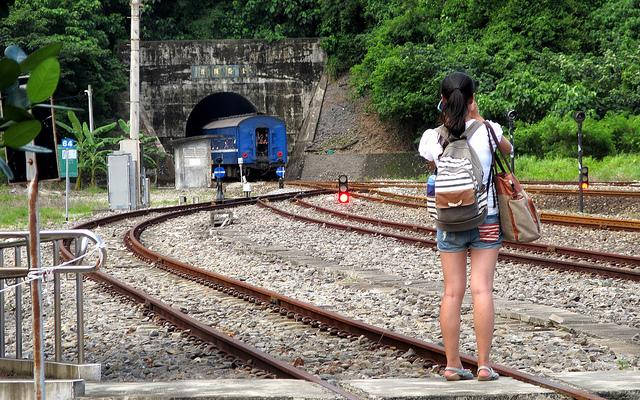What is the girl wearing?

Choices:
A) tiara
B) sandals
C) crown
D) armor sandals 